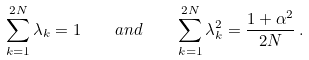Convert formula to latex. <formula><loc_0><loc_0><loc_500><loc_500>\sum _ { k = 1 } ^ { 2 N } \lambda _ { k } = 1 \quad a n d \quad \sum _ { k = 1 } ^ { 2 N } \lambda _ { k } ^ { 2 } = \frac { 1 + \alpha ^ { 2 } } { 2 N } \, .</formula> 